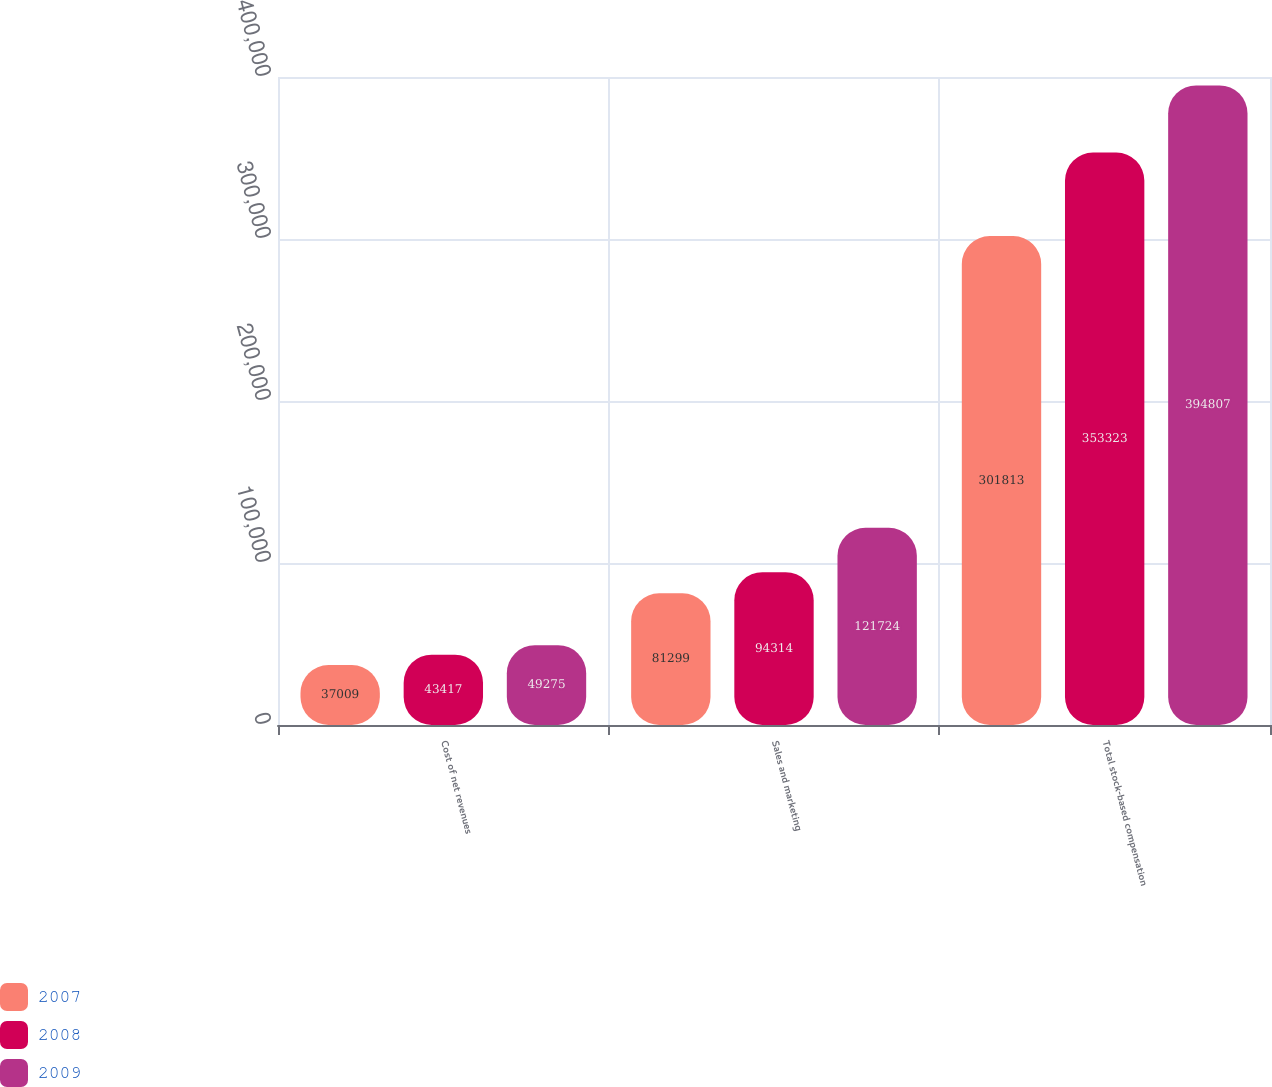Convert chart to OTSL. <chart><loc_0><loc_0><loc_500><loc_500><stacked_bar_chart><ecel><fcel>Cost of net revenues<fcel>Sales and marketing<fcel>Total stock-based compensation<nl><fcel>2007<fcel>37009<fcel>81299<fcel>301813<nl><fcel>2008<fcel>43417<fcel>94314<fcel>353323<nl><fcel>2009<fcel>49275<fcel>121724<fcel>394807<nl></chart> 